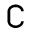<formula> <loc_0><loc_0><loc_500><loc_500>\complement</formula> 